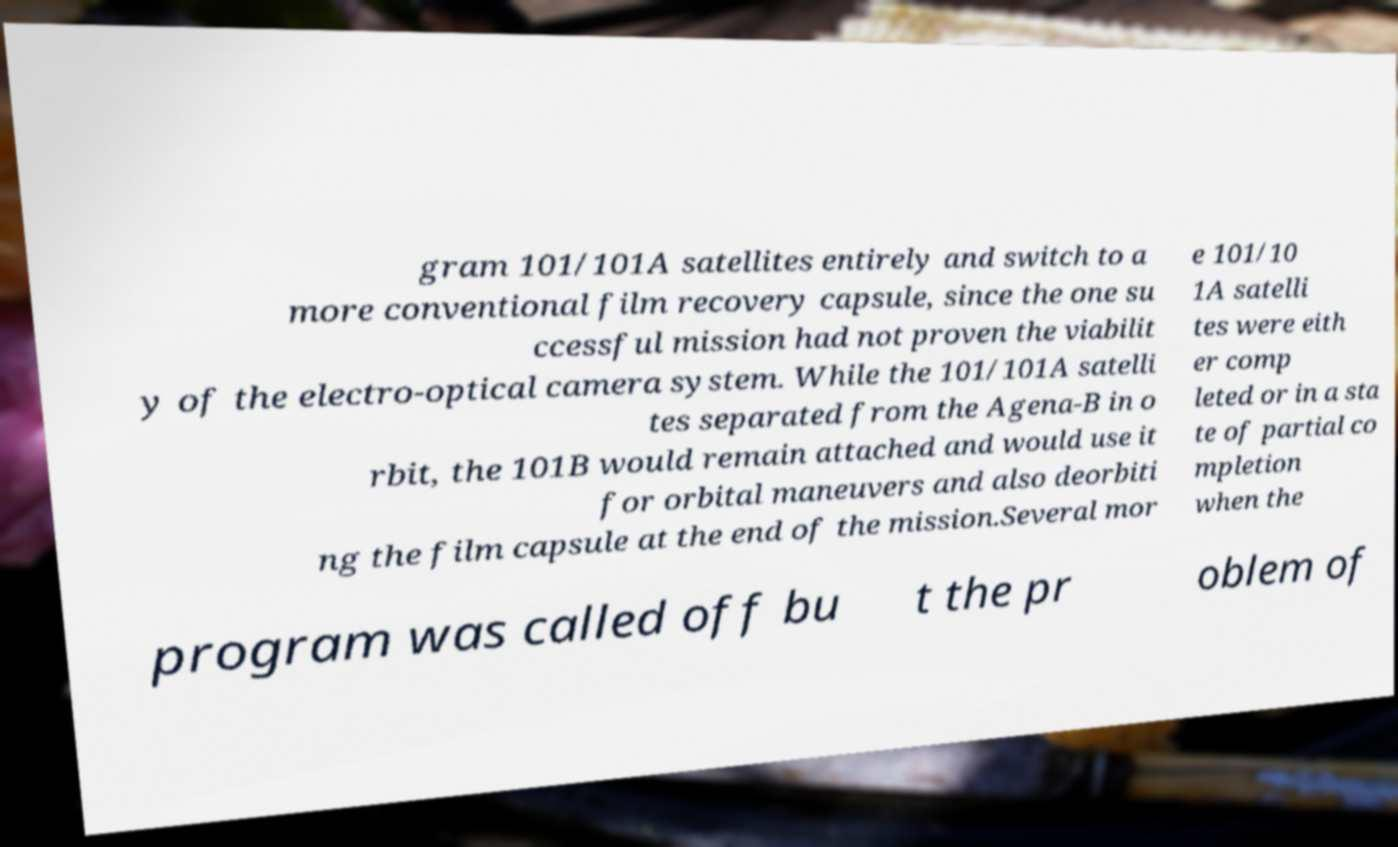Can you accurately transcribe the text from the provided image for me? gram 101/101A satellites entirely and switch to a more conventional film recovery capsule, since the one su ccessful mission had not proven the viabilit y of the electro-optical camera system. While the 101/101A satelli tes separated from the Agena-B in o rbit, the 101B would remain attached and would use it for orbital maneuvers and also deorbiti ng the film capsule at the end of the mission.Several mor e 101/10 1A satelli tes were eith er comp leted or in a sta te of partial co mpletion when the program was called off bu t the pr oblem of 